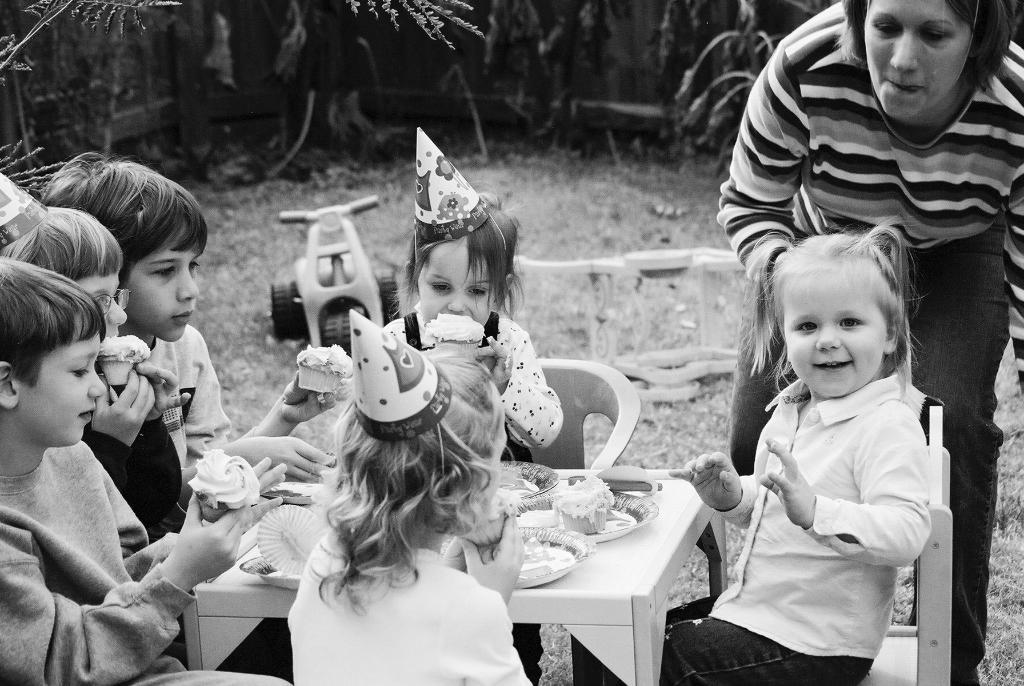What are the kids in the image doing? The group of kids is sitting on chairs in the image. Who else is present in the image besides the kids? There is a woman standing on the right side of the image. What is on the table in the image? There is a table in the image with paper plates and cupcakes present. What can be seen behind the group of kids? There is a vehicle visible behind the group of kids. What type of square object can be seen on the table in the image? There is no square object present on the table in the image. Is there a bottle visible in the image? There is no bottle visible in the image. 